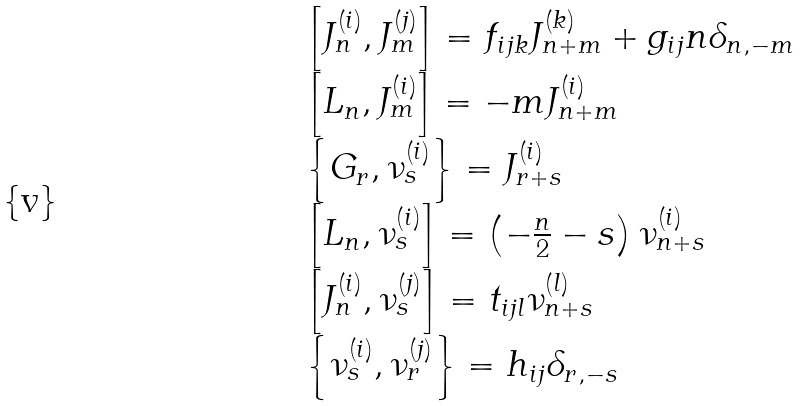Convert formula to latex. <formula><loc_0><loc_0><loc_500><loc_500>\begin{array} { l } { { \left [ J _ { n } ^ { \left ( i \right ) } , J _ { m } ^ { \left ( j \right ) } \right ] = f _ { i j k } J _ { n + m } ^ { \left ( k \right ) } + g _ { i j } n \delta _ { n , - m } } } \\ { { \left [ L _ { n } , J _ { m } ^ { \left ( i \right ) } \right ] = - m J _ { n + m } ^ { \left ( i \right ) } } } \\ { { \left \{ G _ { r } , \nu _ { s } ^ { \left ( i \right ) } \right \} = J _ { r + s } ^ { \left ( i \right ) } } } \\ { { \left [ L _ { n } , \nu _ { s } ^ { \left ( i \right ) } \right ] = \left ( - \frac { n } { 2 } - s \right ) \nu _ { n + s } ^ { \left ( i \right ) } } } \\ { { \left [ J _ { n } ^ { \left ( i \right ) } , \nu _ { s } ^ { \left ( j \right ) } \right ] = t _ { i j l } \nu _ { n + s } ^ { \left ( l \right ) } } } \\ { { \left \{ \nu _ { s } ^ { \left ( i \right ) } , \nu _ { r } ^ { \left ( j \right ) } \right \} = h _ { i j } \delta _ { r , - s } } } \end{array}</formula> 